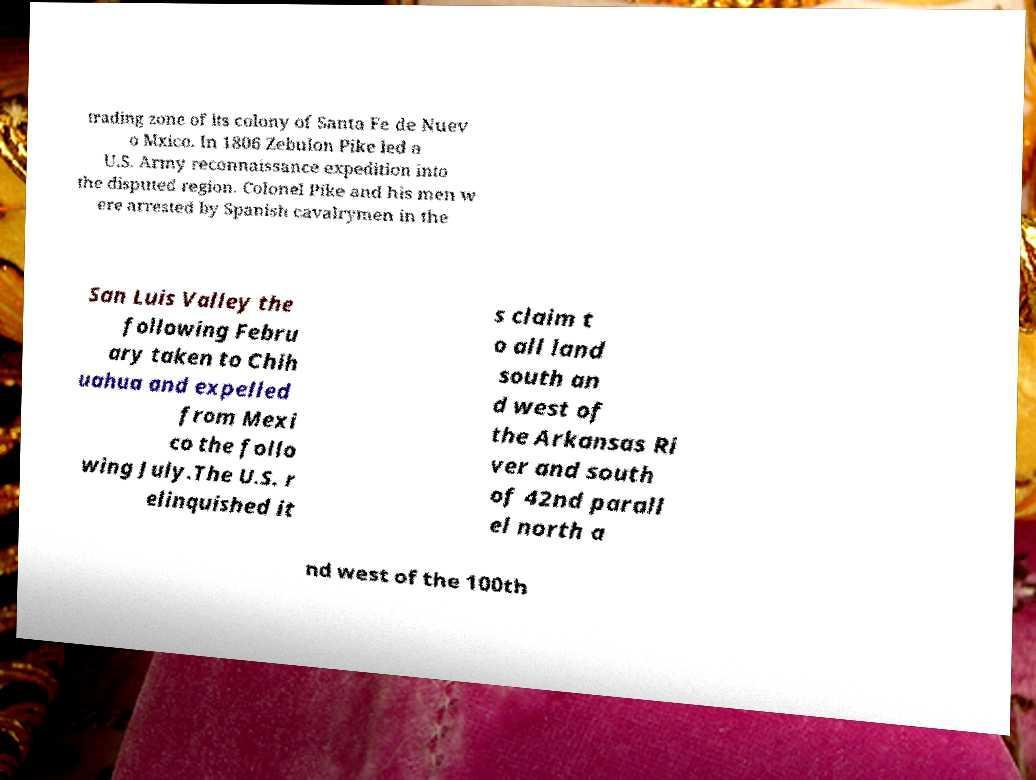Can you read and provide the text displayed in the image?This photo seems to have some interesting text. Can you extract and type it out for me? trading zone of its colony of Santa Fe de Nuev o Mxico. In 1806 Zebulon Pike led a U.S. Army reconnaissance expedition into the disputed region. Colonel Pike and his men w ere arrested by Spanish cavalrymen in the San Luis Valley the following Febru ary taken to Chih uahua and expelled from Mexi co the follo wing July.The U.S. r elinquished it s claim t o all land south an d west of the Arkansas Ri ver and south of 42nd parall el north a nd west of the 100th 